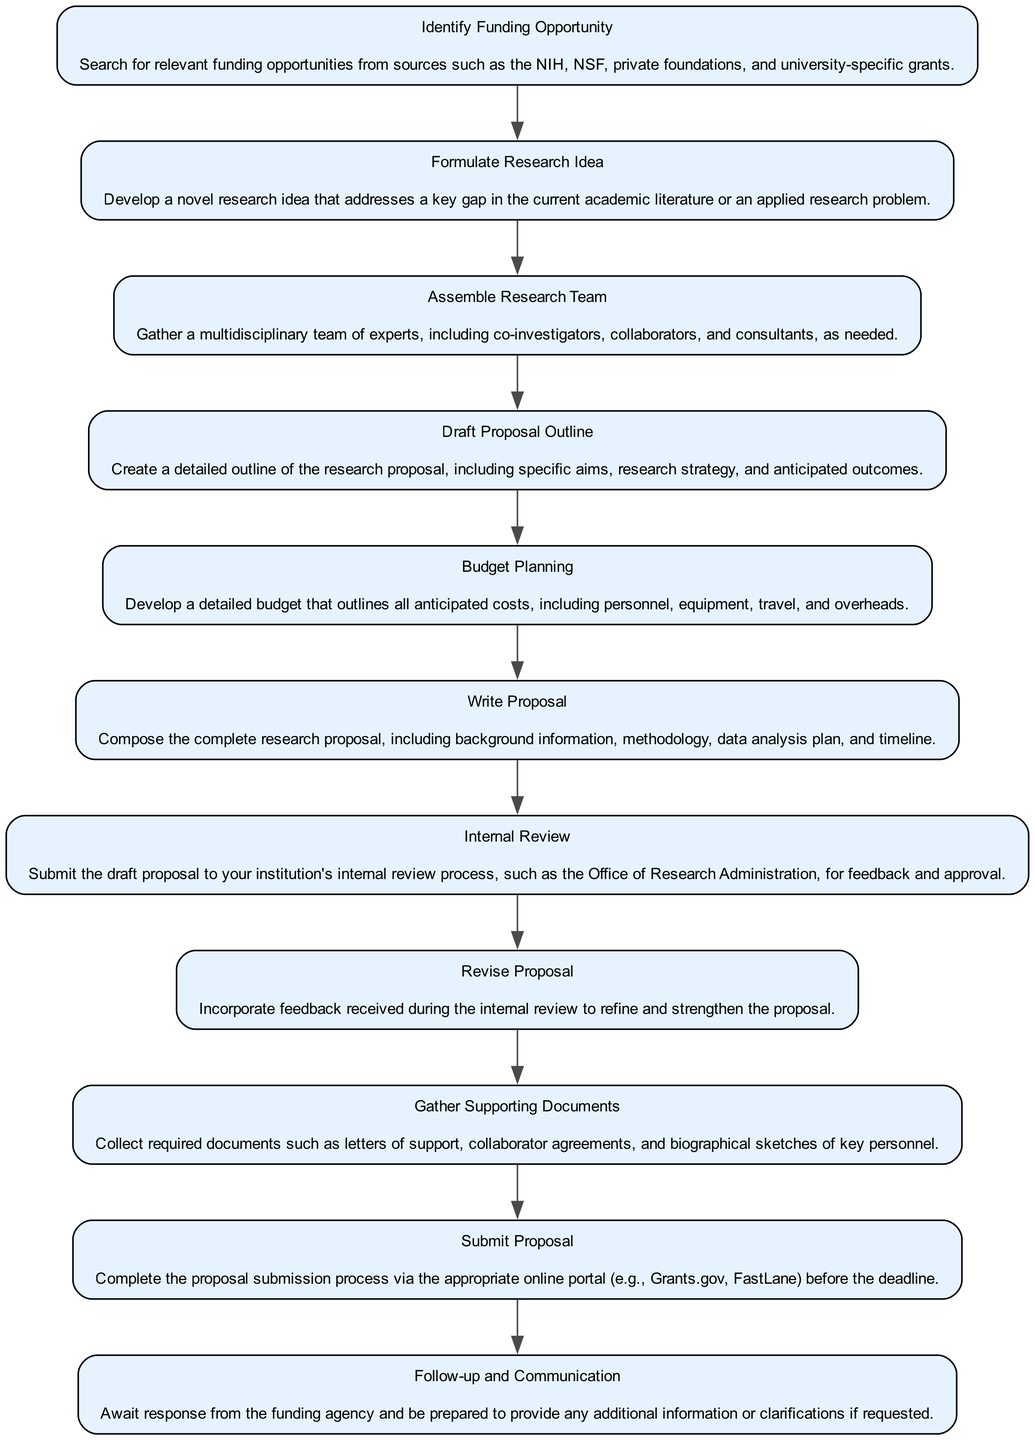What is the first step in the grant proposal lifecycle? The first step listed in the diagram is "Identify Funding Opportunity," which indicates the initiation of the grant proposal process by searching for relevant funding sources.
Answer: Identify Funding Opportunity How many steps are there in the lifecycle? By counting the distinct nodes in the diagram, there are 11 total steps that outline the grant proposal development and submission process.
Answer: 11 What step follows "Assemble Research Team"? According to the sequence in the diagram, the step that comes after "Assemble Research Team" is "Draft Proposal Outline," which indicates that proposal drafting follows team assembly.
Answer: Draft Proposal Outline What happens after the "Internal Review"? After the "Internal Review," the next step is to "Revise Proposal," which indicates that feedback from the internal review leads to proposal revisions.
Answer: Revise Proposal Which step includes collecting required documents? The diagram specifies "Gather Supporting Documents" as the step that involves collecting necessary materials like letters of support and biographical sketches.
Answer: Gather Supporting Documents What is indicated as necessary before submitting the proposal? The diagram highlights that "Internal Review" and "Revise Proposal" are necessary before the actual "Submit Proposal" step, indicating a need for internal feedback and revisions.
Answer: Internal Review and Revise Proposal Is "Budget Planning" a prior step to "Write Proposal"? Yes, in the flowchart, "Budget Planning" occurs before "Write Proposal," which means that financial considerations are set before drafting the full proposal.
Answer: Yes What is the final step of the lifecycle? The last step in the diagram is "Follow-up and Communication," which indicates ongoing interaction with the funding agency after proposal submission.
Answer: Follow-up and Communication What ensures the proposal is refined and strengthened? The step "Revise Proposal" incorporates feedback received during the "Internal Review," ensuring the proposal is improved before submission.
Answer: Revise Proposal 